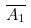Convert formula to latex. <formula><loc_0><loc_0><loc_500><loc_500>\overline { A _ { 1 } }</formula> 